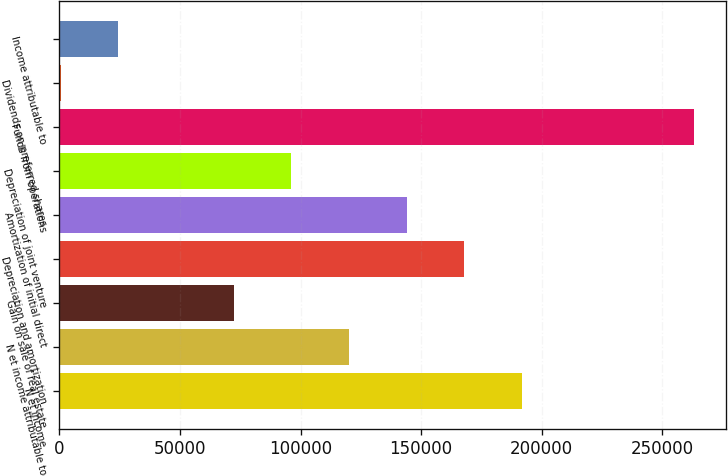<chart> <loc_0><loc_0><loc_500><loc_500><bar_chart><fcel>N et income<fcel>N et income attributable to<fcel>Gain on sale of real estate<fcel>Depreciation and amortization<fcel>Amortization of initial direct<fcel>Depreciation of joint venture<fcel>Funds from operations<fcel>Dividends on preferred shares<fcel>Income attributable to<nl><fcel>191803<fcel>120080<fcel>72264.1<fcel>167895<fcel>143987<fcel>96171.8<fcel>263118<fcel>541<fcel>24448.7<nl></chart> 